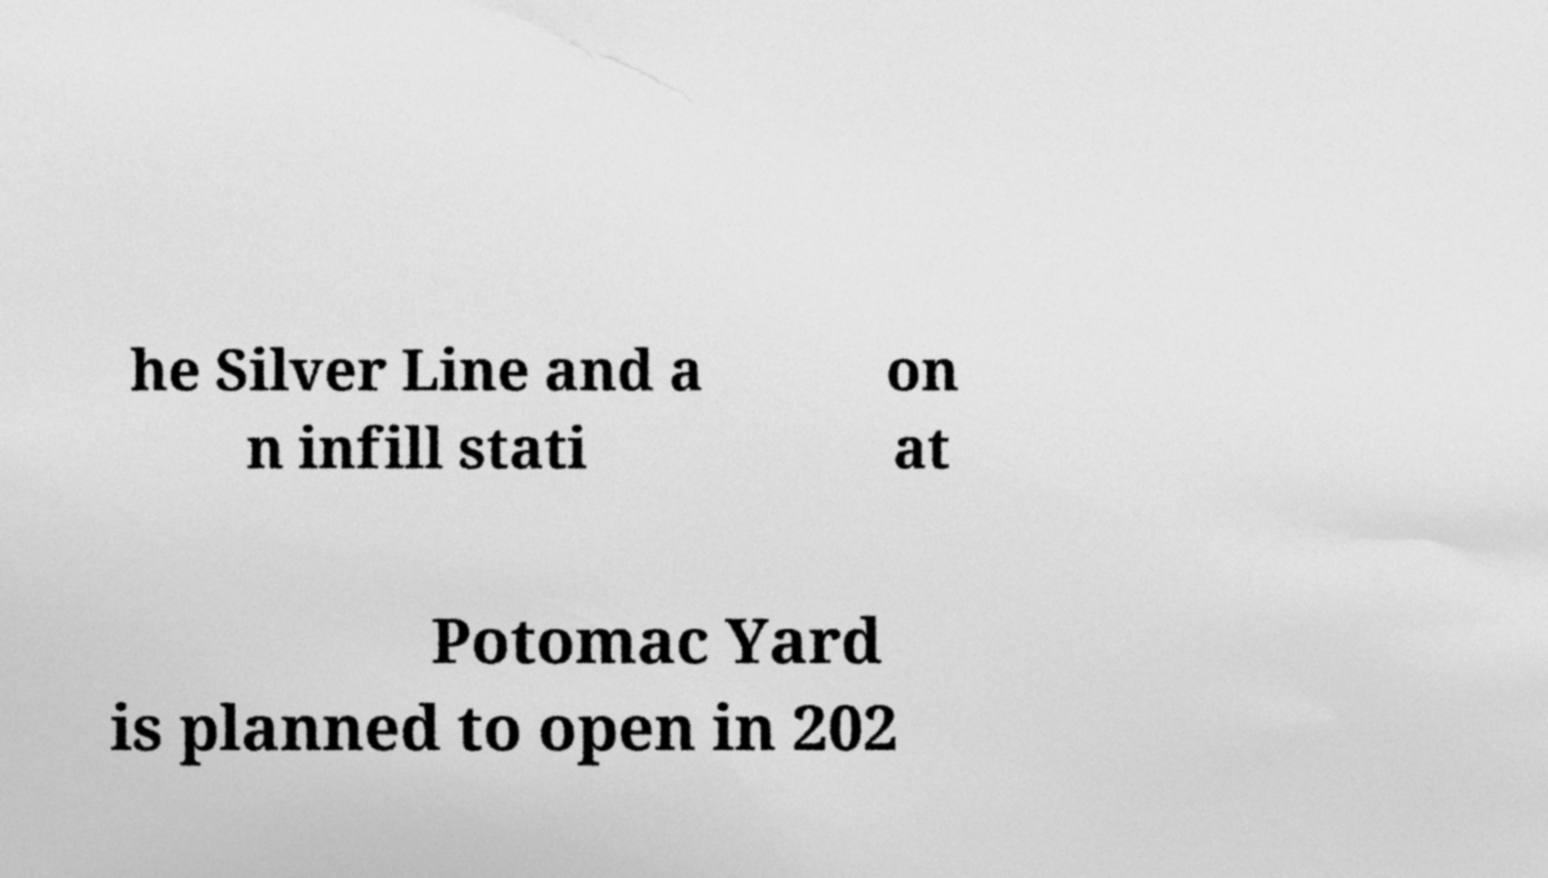Can you read and provide the text displayed in the image?This photo seems to have some interesting text. Can you extract and type it out for me? he Silver Line and a n infill stati on at Potomac Yard is planned to open in 202 